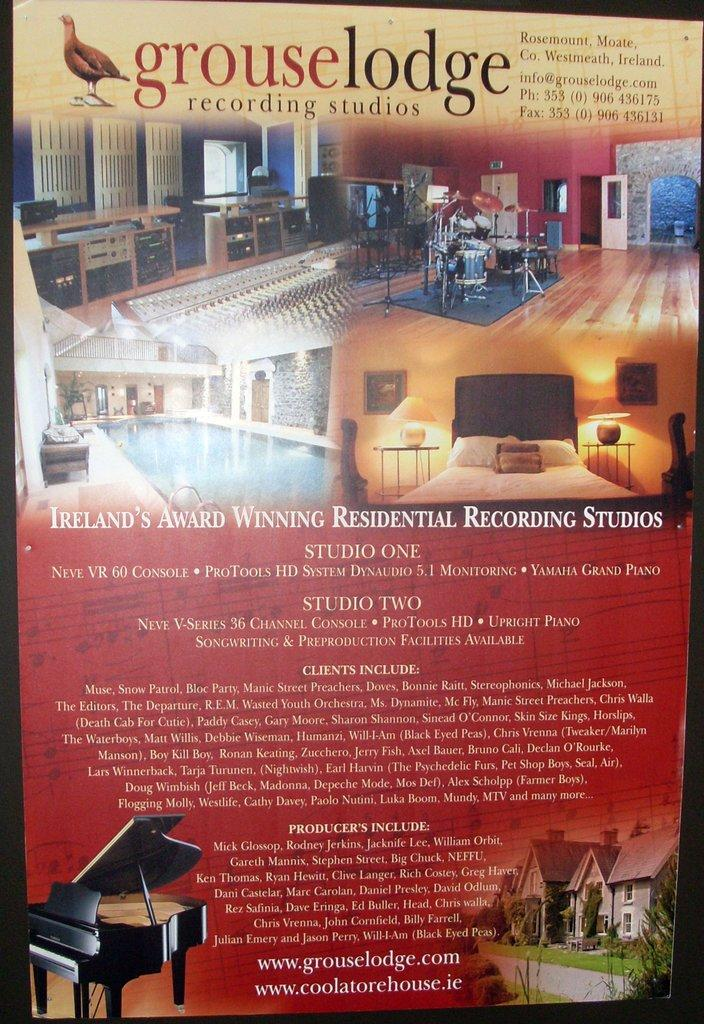What is the main subject of the poster in the image? The poster contains images of a house, swimming pool, kitchen, and musical instruments. Are there any living creatures depicted on the poster? Yes, there is an image of a bird on the poster. What else can be found on the poster besides images? There is text written on the poster. Can you describe the destruction caused by the rainstorm in the image? There is no rainstorm present in the image; it only features a poster with images and text. What type of apple is shown in the image? There is no apple present in the image; the poster contains images of a house, swimming pool, kitchen, musical instruments, and a bird. 